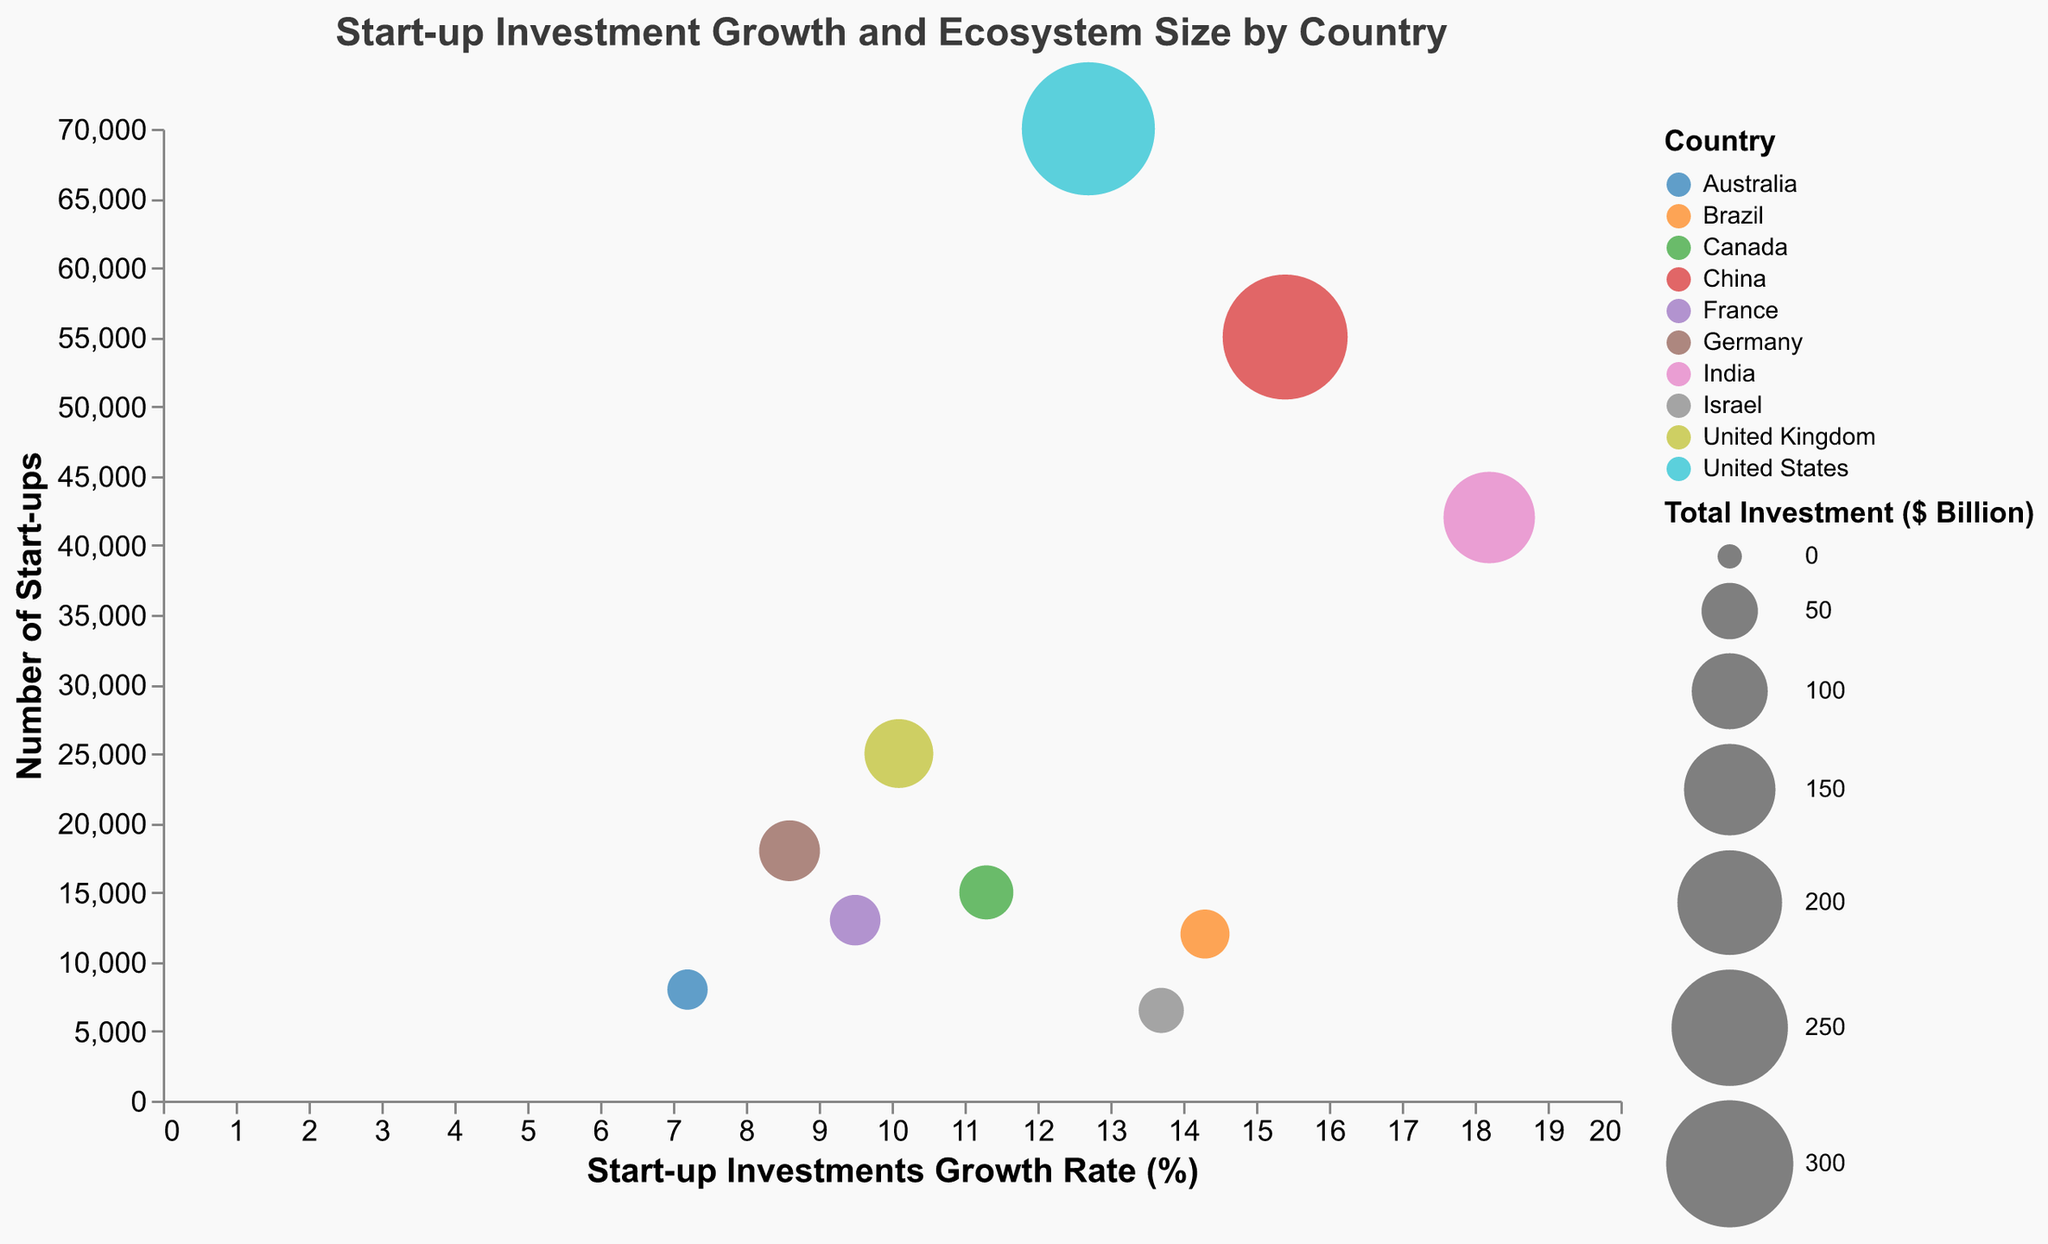What is the start-up investments growth rate for the United States? Look for the United States in the figure and check the x-axis value corresponding to it.
Answer: 12.7% Which country has the highest start-up investments growth rate? Examine the figure for the country with the furthest right bubble on the x-axis.
Answer: India How many start-ups are there in Germany? Identify Germany from the figure and check the y-axis value corresponding to it.
Answer: 18,000 Compare the total investment amounts between Brazil and Israel. Which one is larger? Find Brazil and Israel in the figure, compare the size of their bubbles to see which one is larger.
Answer: Brazil What color represents Australia in the chart? Look for Australia in the figure and identify the color used for its bubble.
Answer: Light blue Estimate the average start-up investments growth rate (%) for Canada and France. Check the x-axis values for Canada (11.3) and France (9.5), then calculate the average: (11.3 + 9.5) / 2 = 10.4.
Answer: 10.4% Between China and India, which country has a higher number of start-ups? Compare the y-axis values for China and India; India is higher.
Answer: India What is the total investment ($ Billion) for the United Kingdom, and how does it compare to France? Look at the size of the bubbles for the United Kingdom (80) and France (38), compare the values.
Answer: United Kingdom has a larger total investment, $80 billion vs. $38 billion If you combine the total investments from Canada and Australia, how does this compare to Brazil? Sum the total investments of Canada (45) and Australia (20): 45 + 20 = 65, then compare to Brazil (35).
Answer: Combined investment (65) is larger than Brazil's (35) Which country's start-up ecosystem has the most significant total investment, and how is it represented in the chart? The United States has the largest total investment, represented by the largest bubble size.
Answer: United States 